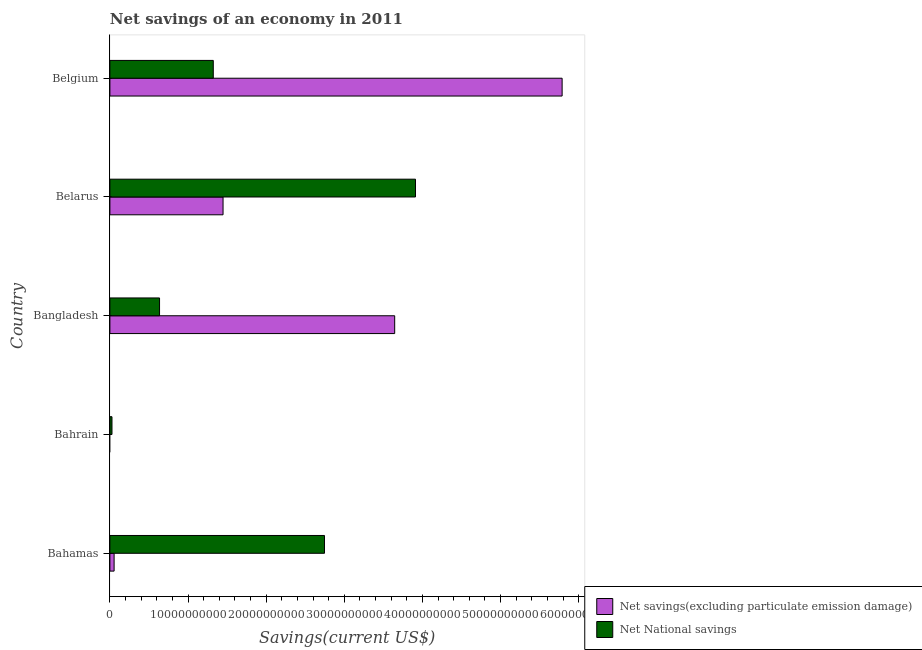How many different coloured bars are there?
Provide a short and direct response. 2. In how many cases, is the number of bars for a given country not equal to the number of legend labels?
Provide a short and direct response. 1. What is the net national savings in Bahamas?
Make the answer very short. 2.75e+1. Across all countries, what is the maximum net savings(excluding particulate emission damage)?
Your answer should be compact. 5.79e+1. Across all countries, what is the minimum net national savings?
Your response must be concise. 2.69e+08. In which country was the net savings(excluding particulate emission damage) maximum?
Offer a very short reply. Belgium. What is the total net national savings in the graph?
Offer a terse response. 8.64e+1. What is the difference between the net national savings in Bahrain and that in Bangladesh?
Your response must be concise. -6.09e+09. What is the difference between the net savings(excluding particulate emission damage) in Belgium and the net national savings in Belarus?
Make the answer very short. 1.88e+1. What is the average net national savings per country?
Ensure brevity in your answer.  1.73e+1. What is the difference between the net savings(excluding particulate emission damage) and net national savings in Bangladesh?
Provide a short and direct response. 3.01e+1. What is the ratio of the net national savings in Bahamas to that in Belgium?
Offer a very short reply. 2.08. What is the difference between the highest and the second highest net savings(excluding particulate emission damage)?
Keep it short and to the point. 2.14e+1. What is the difference between the highest and the lowest net national savings?
Your answer should be compact. 3.88e+1. In how many countries, is the net national savings greater than the average net national savings taken over all countries?
Give a very brief answer. 2. How many bars are there?
Offer a terse response. 9. Are all the bars in the graph horizontal?
Ensure brevity in your answer.  Yes. What is the difference between two consecutive major ticks on the X-axis?
Your answer should be very brief. 1.00e+1. Does the graph contain any zero values?
Keep it short and to the point. Yes. How many legend labels are there?
Give a very brief answer. 2. What is the title of the graph?
Keep it short and to the point. Net savings of an economy in 2011. What is the label or title of the X-axis?
Your answer should be very brief. Savings(current US$). What is the Savings(current US$) in Net savings(excluding particulate emission damage) in Bahamas?
Your answer should be compact. 5.40e+08. What is the Savings(current US$) in Net National savings in Bahamas?
Offer a very short reply. 2.75e+1. What is the Savings(current US$) of Net National savings in Bahrain?
Make the answer very short. 2.69e+08. What is the Savings(current US$) in Net savings(excluding particulate emission damage) in Bangladesh?
Ensure brevity in your answer.  3.65e+1. What is the Savings(current US$) in Net National savings in Bangladesh?
Give a very brief answer. 6.36e+09. What is the Savings(current US$) of Net savings(excluding particulate emission damage) in Belarus?
Offer a terse response. 1.45e+1. What is the Savings(current US$) in Net National savings in Belarus?
Your answer should be compact. 3.91e+1. What is the Savings(current US$) in Net savings(excluding particulate emission damage) in Belgium?
Offer a very short reply. 5.79e+1. What is the Savings(current US$) of Net National savings in Belgium?
Give a very brief answer. 1.32e+1. Across all countries, what is the maximum Savings(current US$) in Net savings(excluding particulate emission damage)?
Provide a short and direct response. 5.79e+1. Across all countries, what is the maximum Savings(current US$) in Net National savings?
Give a very brief answer. 3.91e+1. Across all countries, what is the minimum Savings(current US$) of Net savings(excluding particulate emission damage)?
Provide a short and direct response. 0. Across all countries, what is the minimum Savings(current US$) of Net National savings?
Make the answer very short. 2.69e+08. What is the total Savings(current US$) in Net savings(excluding particulate emission damage) in the graph?
Offer a terse response. 1.09e+11. What is the total Savings(current US$) of Net National savings in the graph?
Your answer should be compact. 8.64e+1. What is the difference between the Savings(current US$) in Net National savings in Bahamas and that in Bahrain?
Offer a very short reply. 2.72e+1. What is the difference between the Savings(current US$) of Net savings(excluding particulate emission damage) in Bahamas and that in Bangladesh?
Provide a succinct answer. -3.59e+1. What is the difference between the Savings(current US$) in Net National savings in Bahamas and that in Bangladesh?
Offer a terse response. 2.11e+1. What is the difference between the Savings(current US$) of Net savings(excluding particulate emission damage) in Bahamas and that in Belarus?
Keep it short and to the point. -1.39e+1. What is the difference between the Savings(current US$) in Net National savings in Bahamas and that in Belarus?
Your answer should be compact. -1.16e+1. What is the difference between the Savings(current US$) in Net savings(excluding particulate emission damage) in Bahamas and that in Belgium?
Keep it short and to the point. -5.73e+1. What is the difference between the Savings(current US$) of Net National savings in Bahamas and that in Belgium?
Give a very brief answer. 1.42e+1. What is the difference between the Savings(current US$) in Net National savings in Bahrain and that in Bangladesh?
Provide a succinct answer. -6.09e+09. What is the difference between the Savings(current US$) of Net National savings in Bahrain and that in Belarus?
Your answer should be compact. -3.88e+1. What is the difference between the Savings(current US$) in Net National savings in Bahrain and that in Belgium?
Keep it short and to the point. -1.30e+1. What is the difference between the Savings(current US$) of Net savings(excluding particulate emission damage) in Bangladesh and that in Belarus?
Your answer should be very brief. 2.20e+1. What is the difference between the Savings(current US$) in Net National savings in Bangladesh and that in Belarus?
Ensure brevity in your answer.  -3.28e+1. What is the difference between the Savings(current US$) of Net savings(excluding particulate emission damage) in Bangladesh and that in Belgium?
Offer a very short reply. -2.14e+1. What is the difference between the Savings(current US$) in Net National savings in Bangladesh and that in Belgium?
Your answer should be very brief. -6.88e+09. What is the difference between the Savings(current US$) of Net savings(excluding particulate emission damage) in Belarus and that in Belgium?
Your answer should be compact. -4.34e+1. What is the difference between the Savings(current US$) of Net National savings in Belarus and that in Belgium?
Offer a very short reply. 2.59e+1. What is the difference between the Savings(current US$) of Net savings(excluding particulate emission damage) in Bahamas and the Savings(current US$) of Net National savings in Bahrain?
Ensure brevity in your answer.  2.72e+08. What is the difference between the Savings(current US$) of Net savings(excluding particulate emission damage) in Bahamas and the Savings(current US$) of Net National savings in Bangladesh?
Your answer should be compact. -5.82e+09. What is the difference between the Savings(current US$) of Net savings(excluding particulate emission damage) in Bahamas and the Savings(current US$) of Net National savings in Belarus?
Your answer should be compact. -3.86e+1. What is the difference between the Savings(current US$) in Net savings(excluding particulate emission damage) in Bahamas and the Savings(current US$) in Net National savings in Belgium?
Your answer should be very brief. -1.27e+1. What is the difference between the Savings(current US$) in Net savings(excluding particulate emission damage) in Bangladesh and the Savings(current US$) in Net National savings in Belarus?
Ensure brevity in your answer.  -2.66e+09. What is the difference between the Savings(current US$) in Net savings(excluding particulate emission damage) in Bangladesh and the Savings(current US$) in Net National savings in Belgium?
Offer a very short reply. 2.32e+1. What is the difference between the Savings(current US$) of Net savings(excluding particulate emission damage) in Belarus and the Savings(current US$) of Net National savings in Belgium?
Your answer should be very brief. 1.25e+09. What is the average Savings(current US$) of Net savings(excluding particulate emission damage) per country?
Ensure brevity in your answer.  2.19e+1. What is the average Savings(current US$) in Net National savings per country?
Your answer should be very brief. 1.73e+1. What is the difference between the Savings(current US$) in Net savings(excluding particulate emission damage) and Savings(current US$) in Net National savings in Bahamas?
Provide a short and direct response. -2.69e+1. What is the difference between the Savings(current US$) in Net savings(excluding particulate emission damage) and Savings(current US$) in Net National savings in Bangladesh?
Ensure brevity in your answer.  3.01e+1. What is the difference between the Savings(current US$) in Net savings(excluding particulate emission damage) and Savings(current US$) in Net National savings in Belarus?
Your answer should be compact. -2.46e+1. What is the difference between the Savings(current US$) of Net savings(excluding particulate emission damage) and Savings(current US$) of Net National savings in Belgium?
Give a very brief answer. 4.46e+1. What is the ratio of the Savings(current US$) of Net National savings in Bahamas to that in Bahrain?
Your answer should be compact. 102.25. What is the ratio of the Savings(current US$) of Net savings(excluding particulate emission damage) in Bahamas to that in Bangladesh?
Keep it short and to the point. 0.01. What is the ratio of the Savings(current US$) in Net National savings in Bahamas to that in Bangladesh?
Your response must be concise. 4.32. What is the ratio of the Savings(current US$) of Net savings(excluding particulate emission damage) in Bahamas to that in Belarus?
Your response must be concise. 0.04. What is the ratio of the Savings(current US$) in Net National savings in Bahamas to that in Belarus?
Give a very brief answer. 0.7. What is the ratio of the Savings(current US$) of Net savings(excluding particulate emission damage) in Bahamas to that in Belgium?
Make the answer very short. 0.01. What is the ratio of the Savings(current US$) of Net National savings in Bahamas to that in Belgium?
Provide a short and direct response. 2.08. What is the ratio of the Savings(current US$) in Net National savings in Bahrain to that in Bangladesh?
Provide a short and direct response. 0.04. What is the ratio of the Savings(current US$) in Net National savings in Bahrain to that in Belarus?
Provide a succinct answer. 0.01. What is the ratio of the Savings(current US$) in Net National savings in Bahrain to that in Belgium?
Your answer should be very brief. 0.02. What is the ratio of the Savings(current US$) in Net savings(excluding particulate emission damage) in Bangladesh to that in Belarus?
Your answer should be compact. 2.52. What is the ratio of the Savings(current US$) of Net National savings in Bangladesh to that in Belarus?
Your response must be concise. 0.16. What is the ratio of the Savings(current US$) in Net savings(excluding particulate emission damage) in Bangladesh to that in Belgium?
Provide a short and direct response. 0.63. What is the ratio of the Savings(current US$) of Net National savings in Bangladesh to that in Belgium?
Your answer should be compact. 0.48. What is the ratio of the Savings(current US$) of Net savings(excluding particulate emission damage) in Belarus to that in Belgium?
Provide a short and direct response. 0.25. What is the ratio of the Savings(current US$) of Net National savings in Belarus to that in Belgium?
Your answer should be very brief. 2.96. What is the difference between the highest and the second highest Savings(current US$) in Net savings(excluding particulate emission damage)?
Provide a succinct answer. 2.14e+1. What is the difference between the highest and the second highest Savings(current US$) in Net National savings?
Give a very brief answer. 1.16e+1. What is the difference between the highest and the lowest Savings(current US$) in Net savings(excluding particulate emission damage)?
Make the answer very short. 5.79e+1. What is the difference between the highest and the lowest Savings(current US$) in Net National savings?
Ensure brevity in your answer.  3.88e+1. 